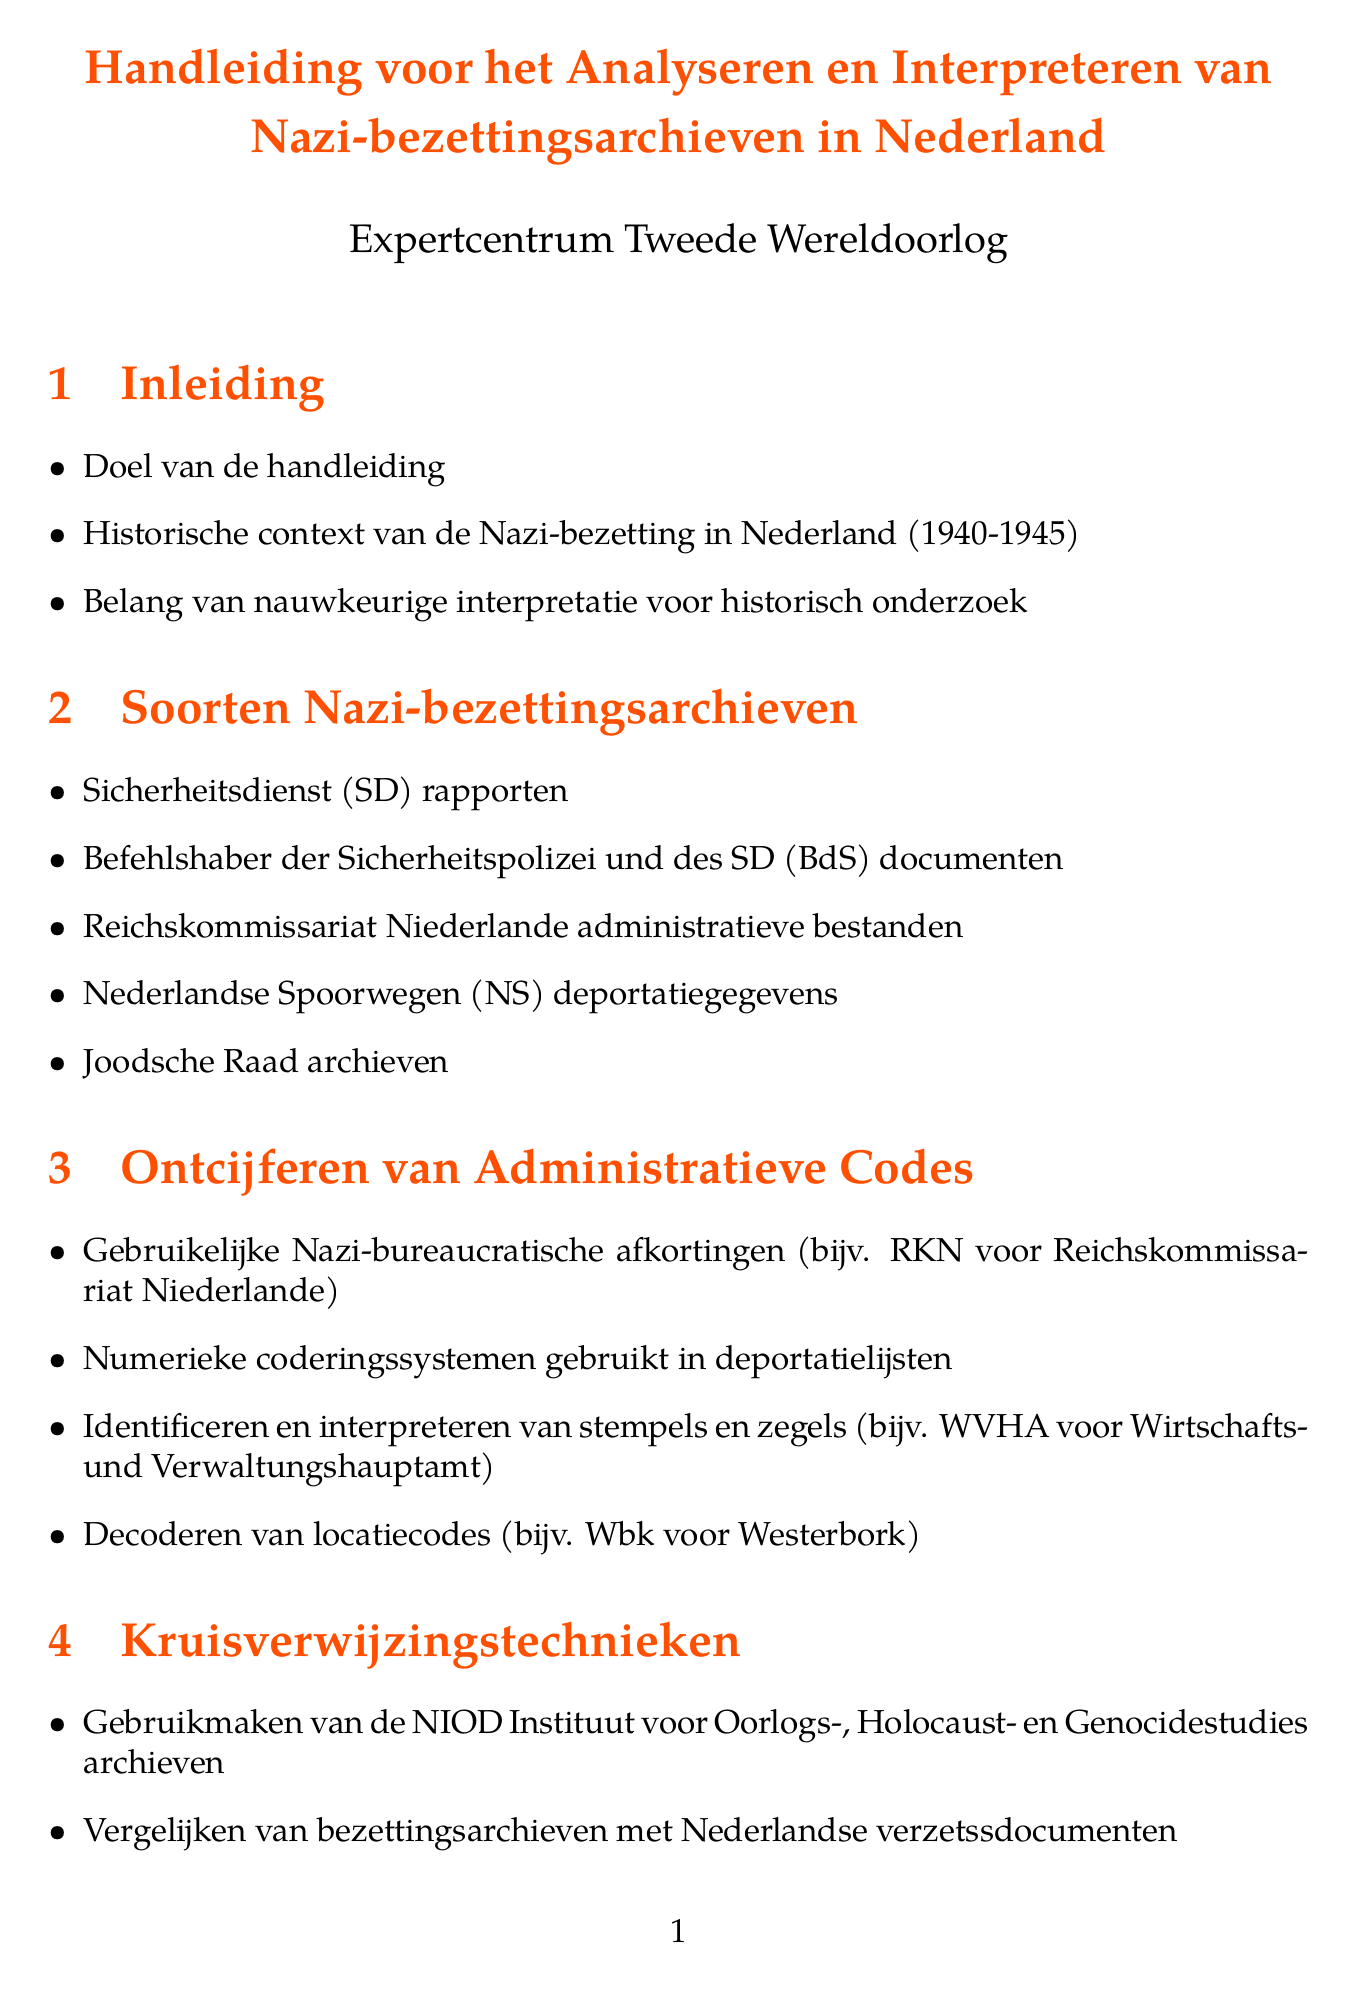What is the manual's title? The title of the manual is detailed at the beginning of the document.
Answer: Handleiding voor het Analyseren en Interpreteren van Nazi-bezettingsarchieven in Nederland What period does the Nazi occupation in the Netherlands cover? The period of the Nazi occupation is specified in the introduction section.
Answer: 1940-1945 Which organization’s reports are included in the types of records section? The manual lists various types of records related to the Nazi occupation.
Answer: Sicherheitsdienst (SD) reports What does RKN stand for? The manual explains common Nazi bureaucratic abbreviations used in its context.
Answer: Reichskommissariat Niederlande What is one method for cross-referencing mentioned in the document? The manual provides various techniques for cross-referencing occupation records.
Answer: Utilizing the NIOD Institute for War, Holocaust and Genocide Studies archives What is a primary ethical consideration when handling Nazi occupation records? The document identifies several ethical considerations relevant to these records.
Answer: Handling sensitive personal information in occupation records Name one case study analyzed in the manual. The manual presents specific case studies related to the Nazi occupation for deeper analysis.
Answer: Analyzing the February Strike of 1941 through multiple record types 